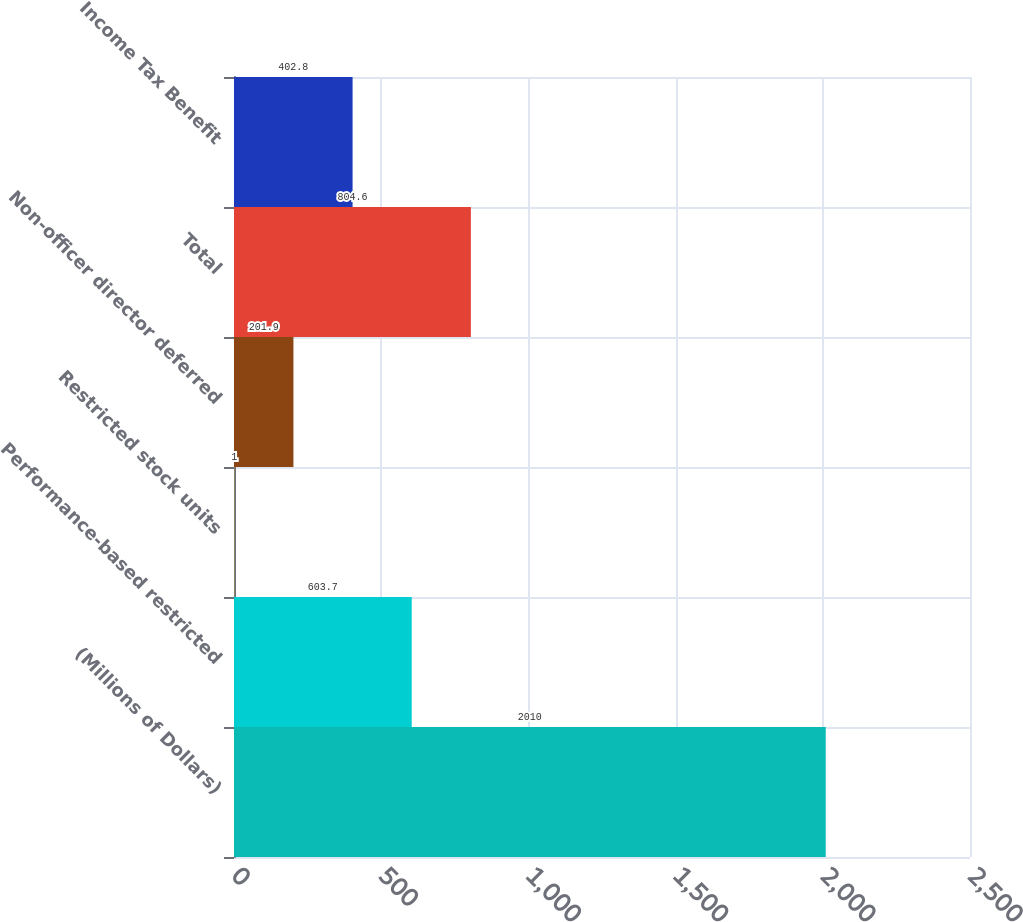Convert chart to OTSL. <chart><loc_0><loc_0><loc_500><loc_500><bar_chart><fcel>(Millions of Dollars)<fcel>Performance-based restricted<fcel>Restricted stock units<fcel>Non-officer director deferred<fcel>Total<fcel>Income Tax Benefit<nl><fcel>2010<fcel>603.7<fcel>1<fcel>201.9<fcel>804.6<fcel>402.8<nl></chart> 